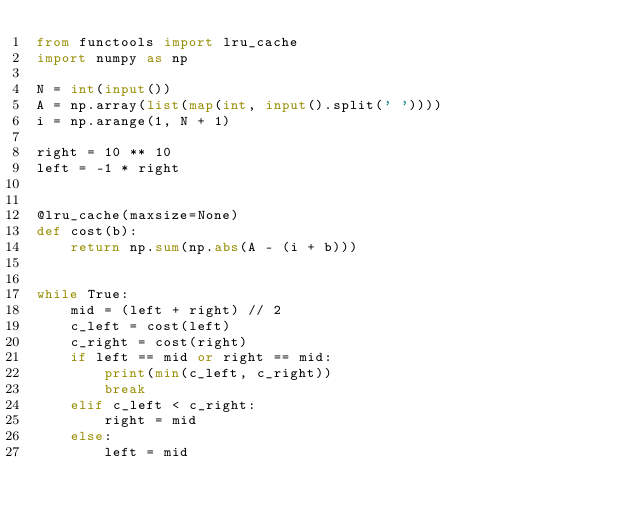Convert code to text. <code><loc_0><loc_0><loc_500><loc_500><_Python_>from functools import lru_cache
import numpy as np

N = int(input())
A = np.array(list(map(int, input().split(' '))))
i = np.arange(1, N + 1)

right = 10 ** 10
left = -1 * right


@lru_cache(maxsize=None)
def cost(b):
    return np.sum(np.abs(A - (i + b)))


while True:
    mid = (left + right) // 2
    c_left = cost(left)
    c_right = cost(right)
    if left == mid or right == mid:
        print(min(c_left, c_right))
        break
    elif c_left < c_right:
        right = mid
    else:
        left = mid
</code> 